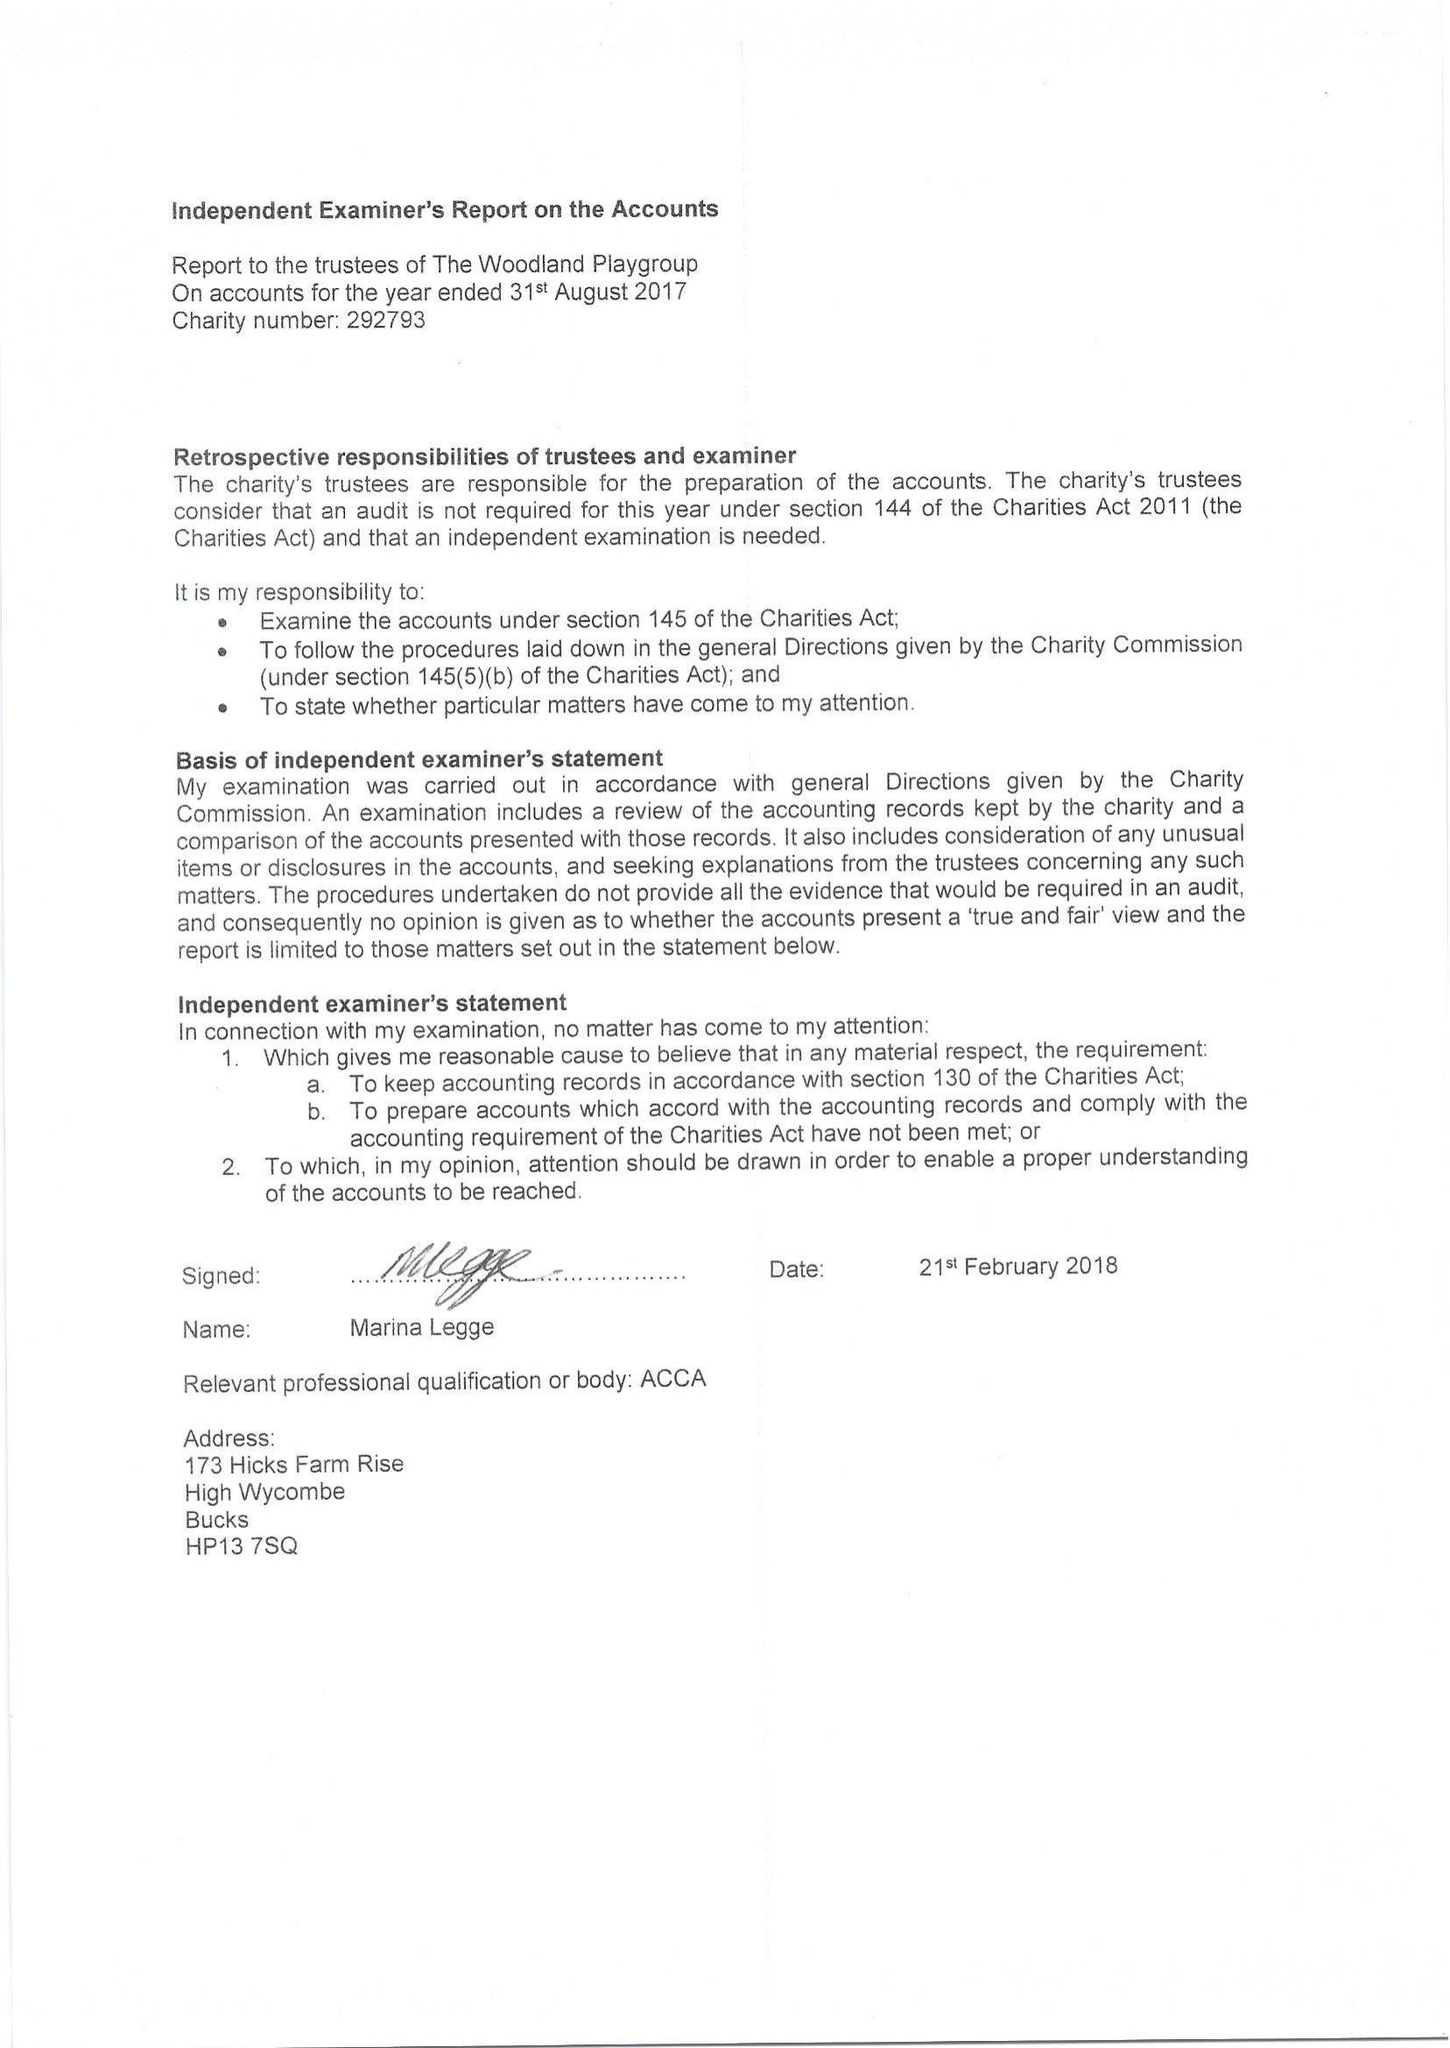What is the value for the charity_name?
Answer the question using a single word or phrase. The Woodland Playgroup 